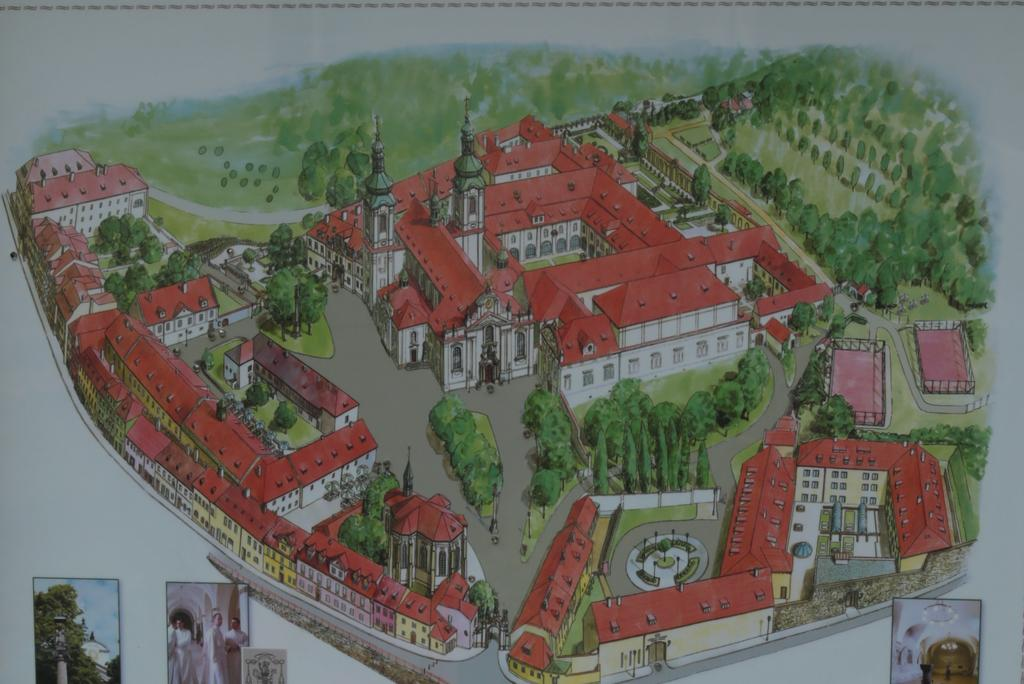What type of artwork is depicted in the image? The image is a painting. What structures can be seen in the painting? There are houses, trees, and walls in the painting. What type of terrain is visible in the painting? There is grass and roads in the painting. What architectural features are present in the painting? There are windows in the painting. What is located at the bottom of the image? At the bottom of the image, there are a few pictures. What type of flesh can be seen in the painting? There is no flesh present in the painting; it is a landscape painting featuring houses, trees, grass, roads, and windows. 